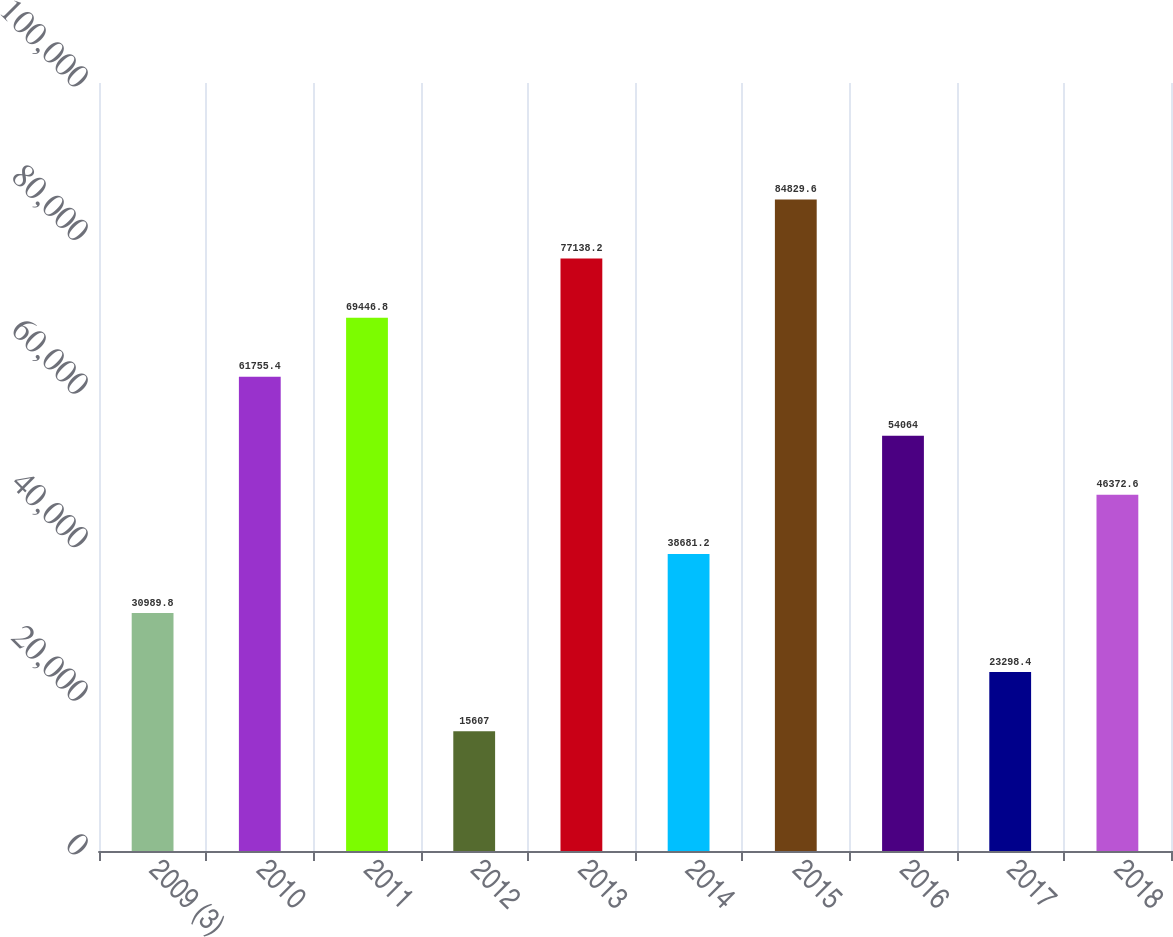Convert chart. <chart><loc_0><loc_0><loc_500><loc_500><bar_chart><fcel>2009 (3)<fcel>2010<fcel>2011<fcel>2012<fcel>2013<fcel>2014<fcel>2015<fcel>2016<fcel>2017<fcel>2018<nl><fcel>30989.8<fcel>61755.4<fcel>69446.8<fcel>15607<fcel>77138.2<fcel>38681.2<fcel>84829.6<fcel>54064<fcel>23298.4<fcel>46372.6<nl></chart> 